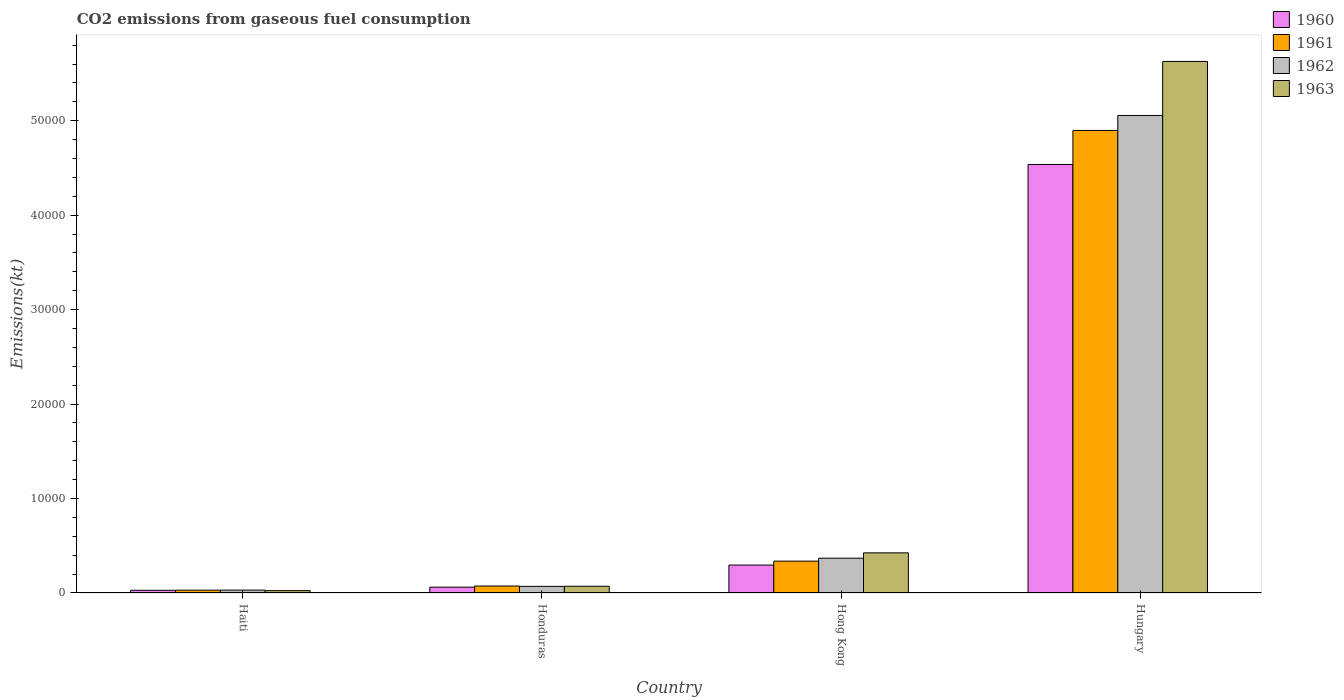How many different coloured bars are there?
Your response must be concise. 4. How many groups of bars are there?
Your answer should be very brief. 4. Are the number of bars per tick equal to the number of legend labels?
Your answer should be compact. Yes. Are the number of bars on each tick of the X-axis equal?
Keep it short and to the point. Yes. What is the label of the 2nd group of bars from the left?
Provide a succinct answer. Honduras. What is the amount of CO2 emitted in 1962 in Haiti?
Keep it short and to the point. 304.36. Across all countries, what is the maximum amount of CO2 emitted in 1963?
Provide a succinct answer. 5.63e+04. Across all countries, what is the minimum amount of CO2 emitted in 1961?
Your response must be concise. 297.03. In which country was the amount of CO2 emitted in 1960 maximum?
Provide a short and direct response. Hungary. In which country was the amount of CO2 emitted in 1963 minimum?
Offer a terse response. Haiti. What is the total amount of CO2 emitted in 1962 in the graph?
Keep it short and to the point. 5.53e+04. What is the difference between the amount of CO2 emitted in 1961 in Hong Kong and that in Hungary?
Offer a terse response. -4.56e+04. What is the difference between the amount of CO2 emitted in 1960 in Honduras and the amount of CO2 emitted in 1962 in Hong Kong?
Your response must be concise. -3069.28. What is the average amount of CO2 emitted in 1962 per country?
Your answer should be compact. 1.38e+04. What is the difference between the amount of CO2 emitted of/in 1961 and amount of CO2 emitted of/in 1960 in Hungary?
Provide a succinct answer. 3604.66. What is the ratio of the amount of CO2 emitted in 1963 in Hong Kong to that in Hungary?
Your answer should be compact. 0.08. What is the difference between the highest and the second highest amount of CO2 emitted in 1963?
Provide a succinct answer. 5.20e+04. What is the difference between the highest and the lowest amount of CO2 emitted in 1962?
Provide a succinct answer. 5.03e+04. In how many countries, is the amount of CO2 emitted in 1960 greater than the average amount of CO2 emitted in 1960 taken over all countries?
Give a very brief answer. 1. Is the sum of the amount of CO2 emitted in 1960 in Haiti and Honduras greater than the maximum amount of CO2 emitted in 1963 across all countries?
Offer a very short reply. No. What does the 1st bar from the left in Hong Kong represents?
Ensure brevity in your answer.  1960. What does the 4th bar from the right in Honduras represents?
Give a very brief answer. 1960. Is it the case that in every country, the sum of the amount of CO2 emitted in 1963 and amount of CO2 emitted in 1961 is greater than the amount of CO2 emitted in 1962?
Give a very brief answer. Yes. How many bars are there?
Offer a very short reply. 16. Are all the bars in the graph horizontal?
Your response must be concise. No. Are the values on the major ticks of Y-axis written in scientific E-notation?
Your response must be concise. No. Does the graph contain any zero values?
Make the answer very short. No. Does the graph contain grids?
Give a very brief answer. No. Where does the legend appear in the graph?
Offer a very short reply. Top right. How many legend labels are there?
Offer a terse response. 4. What is the title of the graph?
Provide a succinct answer. CO2 emissions from gaseous fuel consumption. Does "2007" appear as one of the legend labels in the graph?
Your answer should be compact. No. What is the label or title of the Y-axis?
Provide a succinct answer. Emissions(kt). What is the Emissions(kt) in 1960 in Haiti?
Offer a very short reply. 286.03. What is the Emissions(kt) in 1961 in Haiti?
Keep it short and to the point. 297.03. What is the Emissions(kt) in 1962 in Haiti?
Your response must be concise. 304.36. What is the Emissions(kt) in 1963 in Haiti?
Your answer should be very brief. 249.36. What is the Emissions(kt) of 1960 in Honduras?
Offer a very short reply. 616.06. What is the Emissions(kt) of 1961 in Honduras?
Provide a short and direct response. 737.07. What is the Emissions(kt) in 1962 in Honduras?
Your response must be concise. 700.4. What is the Emissions(kt) in 1963 in Honduras?
Your answer should be very brief. 711.4. What is the Emissions(kt) in 1960 in Hong Kong?
Provide a short and direct response. 2955.6. What is the Emissions(kt) in 1961 in Hong Kong?
Your answer should be very brief. 3373.64. What is the Emissions(kt) in 1962 in Hong Kong?
Your response must be concise. 3685.34. What is the Emissions(kt) in 1963 in Hong Kong?
Provide a short and direct response. 4250.05. What is the Emissions(kt) of 1960 in Hungary?
Give a very brief answer. 4.54e+04. What is the Emissions(kt) of 1961 in Hungary?
Ensure brevity in your answer.  4.90e+04. What is the Emissions(kt) in 1962 in Hungary?
Keep it short and to the point. 5.06e+04. What is the Emissions(kt) in 1963 in Hungary?
Your answer should be compact. 5.63e+04. Across all countries, what is the maximum Emissions(kt) in 1960?
Make the answer very short. 4.54e+04. Across all countries, what is the maximum Emissions(kt) of 1961?
Offer a terse response. 4.90e+04. Across all countries, what is the maximum Emissions(kt) of 1962?
Ensure brevity in your answer.  5.06e+04. Across all countries, what is the maximum Emissions(kt) of 1963?
Make the answer very short. 5.63e+04. Across all countries, what is the minimum Emissions(kt) in 1960?
Offer a very short reply. 286.03. Across all countries, what is the minimum Emissions(kt) in 1961?
Provide a short and direct response. 297.03. Across all countries, what is the minimum Emissions(kt) of 1962?
Ensure brevity in your answer.  304.36. Across all countries, what is the minimum Emissions(kt) of 1963?
Provide a succinct answer. 249.36. What is the total Emissions(kt) of 1960 in the graph?
Give a very brief answer. 4.92e+04. What is the total Emissions(kt) in 1961 in the graph?
Your answer should be very brief. 5.34e+04. What is the total Emissions(kt) of 1962 in the graph?
Your answer should be very brief. 5.53e+04. What is the total Emissions(kt) in 1963 in the graph?
Provide a short and direct response. 6.15e+04. What is the difference between the Emissions(kt) of 1960 in Haiti and that in Honduras?
Give a very brief answer. -330.03. What is the difference between the Emissions(kt) in 1961 in Haiti and that in Honduras?
Provide a short and direct response. -440.04. What is the difference between the Emissions(kt) in 1962 in Haiti and that in Honduras?
Your answer should be very brief. -396.04. What is the difference between the Emissions(kt) in 1963 in Haiti and that in Honduras?
Your response must be concise. -462.04. What is the difference between the Emissions(kt) in 1960 in Haiti and that in Hong Kong?
Keep it short and to the point. -2669.58. What is the difference between the Emissions(kt) of 1961 in Haiti and that in Hong Kong?
Provide a succinct answer. -3076.61. What is the difference between the Emissions(kt) in 1962 in Haiti and that in Hong Kong?
Ensure brevity in your answer.  -3380.97. What is the difference between the Emissions(kt) in 1963 in Haiti and that in Hong Kong?
Ensure brevity in your answer.  -4000.7. What is the difference between the Emissions(kt) of 1960 in Haiti and that in Hungary?
Offer a very short reply. -4.51e+04. What is the difference between the Emissions(kt) in 1961 in Haiti and that in Hungary?
Provide a succinct answer. -4.87e+04. What is the difference between the Emissions(kt) in 1962 in Haiti and that in Hungary?
Ensure brevity in your answer.  -5.03e+04. What is the difference between the Emissions(kt) of 1963 in Haiti and that in Hungary?
Provide a succinct answer. -5.60e+04. What is the difference between the Emissions(kt) of 1960 in Honduras and that in Hong Kong?
Your answer should be very brief. -2339.55. What is the difference between the Emissions(kt) of 1961 in Honduras and that in Hong Kong?
Keep it short and to the point. -2636.57. What is the difference between the Emissions(kt) of 1962 in Honduras and that in Hong Kong?
Offer a very short reply. -2984.94. What is the difference between the Emissions(kt) in 1963 in Honduras and that in Hong Kong?
Offer a terse response. -3538.66. What is the difference between the Emissions(kt) in 1960 in Honduras and that in Hungary?
Keep it short and to the point. -4.48e+04. What is the difference between the Emissions(kt) in 1961 in Honduras and that in Hungary?
Provide a short and direct response. -4.82e+04. What is the difference between the Emissions(kt) in 1962 in Honduras and that in Hungary?
Provide a short and direct response. -4.99e+04. What is the difference between the Emissions(kt) in 1963 in Honduras and that in Hungary?
Offer a very short reply. -5.56e+04. What is the difference between the Emissions(kt) of 1960 in Hong Kong and that in Hungary?
Your answer should be very brief. -4.24e+04. What is the difference between the Emissions(kt) of 1961 in Hong Kong and that in Hungary?
Keep it short and to the point. -4.56e+04. What is the difference between the Emissions(kt) of 1962 in Hong Kong and that in Hungary?
Your answer should be very brief. -4.69e+04. What is the difference between the Emissions(kt) in 1963 in Hong Kong and that in Hungary?
Your answer should be very brief. -5.20e+04. What is the difference between the Emissions(kt) in 1960 in Haiti and the Emissions(kt) in 1961 in Honduras?
Make the answer very short. -451.04. What is the difference between the Emissions(kt) in 1960 in Haiti and the Emissions(kt) in 1962 in Honduras?
Give a very brief answer. -414.37. What is the difference between the Emissions(kt) in 1960 in Haiti and the Emissions(kt) in 1963 in Honduras?
Provide a short and direct response. -425.37. What is the difference between the Emissions(kt) of 1961 in Haiti and the Emissions(kt) of 1962 in Honduras?
Offer a terse response. -403.37. What is the difference between the Emissions(kt) of 1961 in Haiti and the Emissions(kt) of 1963 in Honduras?
Keep it short and to the point. -414.37. What is the difference between the Emissions(kt) of 1962 in Haiti and the Emissions(kt) of 1963 in Honduras?
Ensure brevity in your answer.  -407.04. What is the difference between the Emissions(kt) in 1960 in Haiti and the Emissions(kt) in 1961 in Hong Kong?
Give a very brief answer. -3087.61. What is the difference between the Emissions(kt) of 1960 in Haiti and the Emissions(kt) of 1962 in Hong Kong?
Your response must be concise. -3399.31. What is the difference between the Emissions(kt) of 1960 in Haiti and the Emissions(kt) of 1963 in Hong Kong?
Your answer should be compact. -3964.03. What is the difference between the Emissions(kt) in 1961 in Haiti and the Emissions(kt) in 1962 in Hong Kong?
Ensure brevity in your answer.  -3388.31. What is the difference between the Emissions(kt) of 1961 in Haiti and the Emissions(kt) of 1963 in Hong Kong?
Ensure brevity in your answer.  -3953.03. What is the difference between the Emissions(kt) in 1962 in Haiti and the Emissions(kt) in 1963 in Hong Kong?
Offer a terse response. -3945.69. What is the difference between the Emissions(kt) of 1960 in Haiti and the Emissions(kt) of 1961 in Hungary?
Offer a very short reply. -4.87e+04. What is the difference between the Emissions(kt) of 1960 in Haiti and the Emissions(kt) of 1962 in Hungary?
Give a very brief answer. -5.03e+04. What is the difference between the Emissions(kt) of 1960 in Haiti and the Emissions(kt) of 1963 in Hungary?
Provide a succinct answer. -5.60e+04. What is the difference between the Emissions(kt) of 1961 in Haiti and the Emissions(kt) of 1962 in Hungary?
Offer a terse response. -5.03e+04. What is the difference between the Emissions(kt) of 1961 in Haiti and the Emissions(kt) of 1963 in Hungary?
Offer a terse response. -5.60e+04. What is the difference between the Emissions(kt) in 1962 in Haiti and the Emissions(kt) in 1963 in Hungary?
Offer a terse response. -5.60e+04. What is the difference between the Emissions(kt) in 1960 in Honduras and the Emissions(kt) in 1961 in Hong Kong?
Give a very brief answer. -2757.58. What is the difference between the Emissions(kt) in 1960 in Honduras and the Emissions(kt) in 1962 in Hong Kong?
Offer a terse response. -3069.28. What is the difference between the Emissions(kt) of 1960 in Honduras and the Emissions(kt) of 1963 in Hong Kong?
Offer a terse response. -3634. What is the difference between the Emissions(kt) of 1961 in Honduras and the Emissions(kt) of 1962 in Hong Kong?
Offer a terse response. -2948.27. What is the difference between the Emissions(kt) in 1961 in Honduras and the Emissions(kt) in 1963 in Hong Kong?
Your response must be concise. -3512.99. What is the difference between the Emissions(kt) in 1962 in Honduras and the Emissions(kt) in 1963 in Hong Kong?
Make the answer very short. -3549.66. What is the difference between the Emissions(kt) of 1960 in Honduras and the Emissions(kt) of 1961 in Hungary?
Your answer should be compact. -4.84e+04. What is the difference between the Emissions(kt) in 1960 in Honduras and the Emissions(kt) in 1962 in Hungary?
Offer a terse response. -4.99e+04. What is the difference between the Emissions(kt) of 1960 in Honduras and the Emissions(kt) of 1963 in Hungary?
Give a very brief answer. -5.57e+04. What is the difference between the Emissions(kt) of 1961 in Honduras and the Emissions(kt) of 1962 in Hungary?
Your response must be concise. -4.98e+04. What is the difference between the Emissions(kt) of 1961 in Honduras and the Emissions(kt) of 1963 in Hungary?
Your answer should be very brief. -5.55e+04. What is the difference between the Emissions(kt) in 1962 in Honduras and the Emissions(kt) in 1963 in Hungary?
Provide a succinct answer. -5.56e+04. What is the difference between the Emissions(kt) in 1960 in Hong Kong and the Emissions(kt) in 1961 in Hungary?
Keep it short and to the point. -4.60e+04. What is the difference between the Emissions(kt) of 1960 in Hong Kong and the Emissions(kt) of 1962 in Hungary?
Your answer should be compact. -4.76e+04. What is the difference between the Emissions(kt) of 1960 in Hong Kong and the Emissions(kt) of 1963 in Hungary?
Provide a short and direct response. -5.33e+04. What is the difference between the Emissions(kt) of 1961 in Hong Kong and the Emissions(kt) of 1962 in Hungary?
Ensure brevity in your answer.  -4.72e+04. What is the difference between the Emissions(kt) in 1961 in Hong Kong and the Emissions(kt) in 1963 in Hungary?
Provide a succinct answer. -5.29e+04. What is the difference between the Emissions(kt) of 1962 in Hong Kong and the Emissions(kt) of 1963 in Hungary?
Offer a very short reply. -5.26e+04. What is the average Emissions(kt) in 1960 per country?
Make the answer very short. 1.23e+04. What is the average Emissions(kt) in 1961 per country?
Your response must be concise. 1.33e+04. What is the average Emissions(kt) in 1962 per country?
Give a very brief answer. 1.38e+04. What is the average Emissions(kt) of 1963 per country?
Your answer should be compact. 1.54e+04. What is the difference between the Emissions(kt) of 1960 and Emissions(kt) of 1961 in Haiti?
Offer a terse response. -11. What is the difference between the Emissions(kt) in 1960 and Emissions(kt) in 1962 in Haiti?
Your answer should be very brief. -18.34. What is the difference between the Emissions(kt) of 1960 and Emissions(kt) of 1963 in Haiti?
Provide a short and direct response. 36.67. What is the difference between the Emissions(kt) of 1961 and Emissions(kt) of 1962 in Haiti?
Your response must be concise. -7.33. What is the difference between the Emissions(kt) of 1961 and Emissions(kt) of 1963 in Haiti?
Give a very brief answer. 47.67. What is the difference between the Emissions(kt) of 1962 and Emissions(kt) of 1963 in Haiti?
Offer a terse response. 55.01. What is the difference between the Emissions(kt) in 1960 and Emissions(kt) in 1961 in Honduras?
Your answer should be compact. -121.01. What is the difference between the Emissions(kt) in 1960 and Emissions(kt) in 1962 in Honduras?
Make the answer very short. -84.34. What is the difference between the Emissions(kt) of 1960 and Emissions(kt) of 1963 in Honduras?
Give a very brief answer. -95.34. What is the difference between the Emissions(kt) in 1961 and Emissions(kt) in 1962 in Honduras?
Provide a succinct answer. 36.67. What is the difference between the Emissions(kt) of 1961 and Emissions(kt) of 1963 in Honduras?
Keep it short and to the point. 25.67. What is the difference between the Emissions(kt) in 1962 and Emissions(kt) in 1963 in Honduras?
Offer a terse response. -11. What is the difference between the Emissions(kt) of 1960 and Emissions(kt) of 1961 in Hong Kong?
Your answer should be very brief. -418.04. What is the difference between the Emissions(kt) of 1960 and Emissions(kt) of 1962 in Hong Kong?
Offer a terse response. -729.73. What is the difference between the Emissions(kt) of 1960 and Emissions(kt) of 1963 in Hong Kong?
Ensure brevity in your answer.  -1294.45. What is the difference between the Emissions(kt) of 1961 and Emissions(kt) of 1962 in Hong Kong?
Offer a terse response. -311.69. What is the difference between the Emissions(kt) in 1961 and Emissions(kt) in 1963 in Hong Kong?
Make the answer very short. -876.41. What is the difference between the Emissions(kt) of 1962 and Emissions(kt) of 1963 in Hong Kong?
Keep it short and to the point. -564.72. What is the difference between the Emissions(kt) of 1960 and Emissions(kt) of 1961 in Hungary?
Your answer should be compact. -3604.66. What is the difference between the Emissions(kt) in 1960 and Emissions(kt) in 1962 in Hungary?
Make the answer very short. -5188.81. What is the difference between the Emissions(kt) of 1960 and Emissions(kt) of 1963 in Hungary?
Your response must be concise. -1.09e+04. What is the difference between the Emissions(kt) in 1961 and Emissions(kt) in 1962 in Hungary?
Ensure brevity in your answer.  -1584.14. What is the difference between the Emissions(kt) of 1961 and Emissions(kt) of 1963 in Hungary?
Offer a terse response. -7304.66. What is the difference between the Emissions(kt) of 1962 and Emissions(kt) of 1963 in Hungary?
Make the answer very short. -5720.52. What is the ratio of the Emissions(kt) of 1960 in Haiti to that in Honduras?
Your answer should be compact. 0.46. What is the ratio of the Emissions(kt) in 1961 in Haiti to that in Honduras?
Ensure brevity in your answer.  0.4. What is the ratio of the Emissions(kt) of 1962 in Haiti to that in Honduras?
Your answer should be very brief. 0.43. What is the ratio of the Emissions(kt) in 1963 in Haiti to that in Honduras?
Provide a succinct answer. 0.35. What is the ratio of the Emissions(kt) of 1960 in Haiti to that in Hong Kong?
Give a very brief answer. 0.1. What is the ratio of the Emissions(kt) in 1961 in Haiti to that in Hong Kong?
Ensure brevity in your answer.  0.09. What is the ratio of the Emissions(kt) in 1962 in Haiti to that in Hong Kong?
Provide a succinct answer. 0.08. What is the ratio of the Emissions(kt) of 1963 in Haiti to that in Hong Kong?
Keep it short and to the point. 0.06. What is the ratio of the Emissions(kt) of 1960 in Haiti to that in Hungary?
Offer a very short reply. 0.01. What is the ratio of the Emissions(kt) in 1961 in Haiti to that in Hungary?
Offer a very short reply. 0.01. What is the ratio of the Emissions(kt) of 1962 in Haiti to that in Hungary?
Your response must be concise. 0.01. What is the ratio of the Emissions(kt) in 1963 in Haiti to that in Hungary?
Your answer should be compact. 0. What is the ratio of the Emissions(kt) of 1960 in Honduras to that in Hong Kong?
Keep it short and to the point. 0.21. What is the ratio of the Emissions(kt) in 1961 in Honduras to that in Hong Kong?
Your answer should be very brief. 0.22. What is the ratio of the Emissions(kt) in 1962 in Honduras to that in Hong Kong?
Make the answer very short. 0.19. What is the ratio of the Emissions(kt) in 1963 in Honduras to that in Hong Kong?
Offer a terse response. 0.17. What is the ratio of the Emissions(kt) in 1960 in Honduras to that in Hungary?
Give a very brief answer. 0.01. What is the ratio of the Emissions(kt) of 1961 in Honduras to that in Hungary?
Your answer should be very brief. 0.01. What is the ratio of the Emissions(kt) of 1962 in Honduras to that in Hungary?
Offer a terse response. 0.01. What is the ratio of the Emissions(kt) in 1963 in Honduras to that in Hungary?
Keep it short and to the point. 0.01. What is the ratio of the Emissions(kt) in 1960 in Hong Kong to that in Hungary?
Provide a succinct answer. 0.07. What is the ratio of the Emissions(kt) in 1961 in Hong Kong to that in Hungary?
Make the answer very short. 0.07. What is the ratio of the Emissions(kt) in 1962 in Hong Kong to that in Hungary?
Your response must be concise. 0.07. What is the ratio of the Emissions(kt) of 1963 in Hong Kong to that in Hungary?
Keep it short and to the point. 0.08. What is the difference between the highest and the second highest Emissions(kt) in 1960?
Give a very brief answer. 4.24e+04. What is the difference between the highest and the second highest Emissions(kt) of 1961?
Your answer should be compact. 4.56e+04. What is the difference between the highest and the second highest Emissions(kt) in 1962?
Ensure brevity in your answer.  4.69e+04. What is the difference between the highest and the second highest Emissions(kt) in 1963?
Give a very brief answer. 5.20e+04. What is the difference between the highest and the lowest Emissions(kt) of 1960?
Your answer should be compact. 4.51e+04. What is the difference between the highest and the lowest Emissions(kt) of 1961?
Ensure brevity in your answer.  4.87e+04. What is the difference between the highest and the lowest Emissions(kt) of 1962?
Keep it short and to the point. 5.03e+04. What is the difference between the highest and the lowest Emissions(kt) in 1963?
Your answer should be very brief. 5.60e+04. 